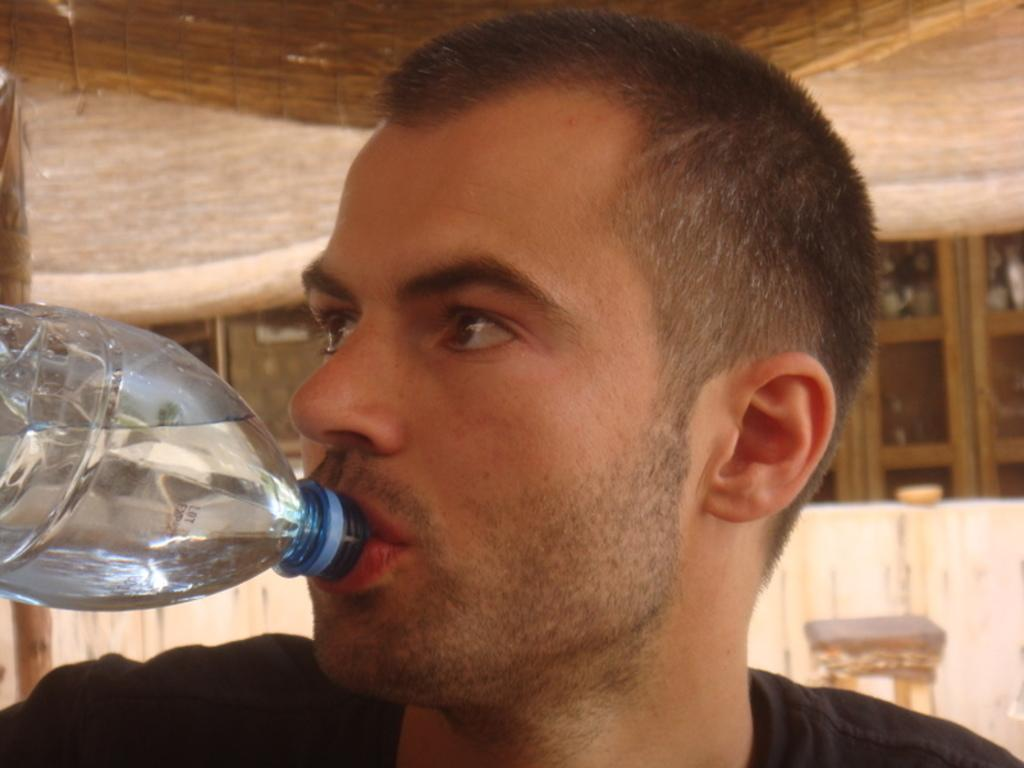Who is present in the image? There is a man in the image. What is the man doing in the image? The man is drinking water. What type of achievement is the man celebrating in the image? There is no indication in the image that the man is celebrating any achievement. 